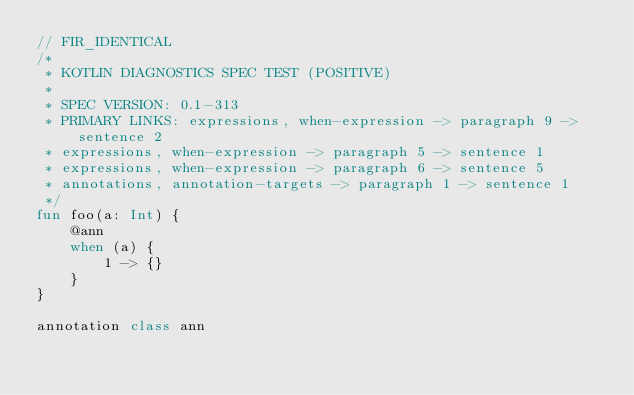<code> <loc_0><loc_0><loc_500><loc_500><_Kotlin_>// FIR_IDENTICAL
/*
 * KOTLIN DIAGNOSTICS SPEC TEST (POSITIVE)
 *
 * SPEC VERSION: 0.1-313
 * PRIMARY LINKS: expressions, when-expression -> paragraph 9 -> sentence 2
 * expressions, when-expression -> paragraph 5 -> sentence 1
 * expressions, when-expression -> paragraph 6 -> sentence 5
 * annotations, annotation-targets -> paragraph 1 -> sentence 1
 */
fun foo(a: Int) {
    @ann
    when (a) {
        1 -> {}
    }
}

annotation class ann
</code> 